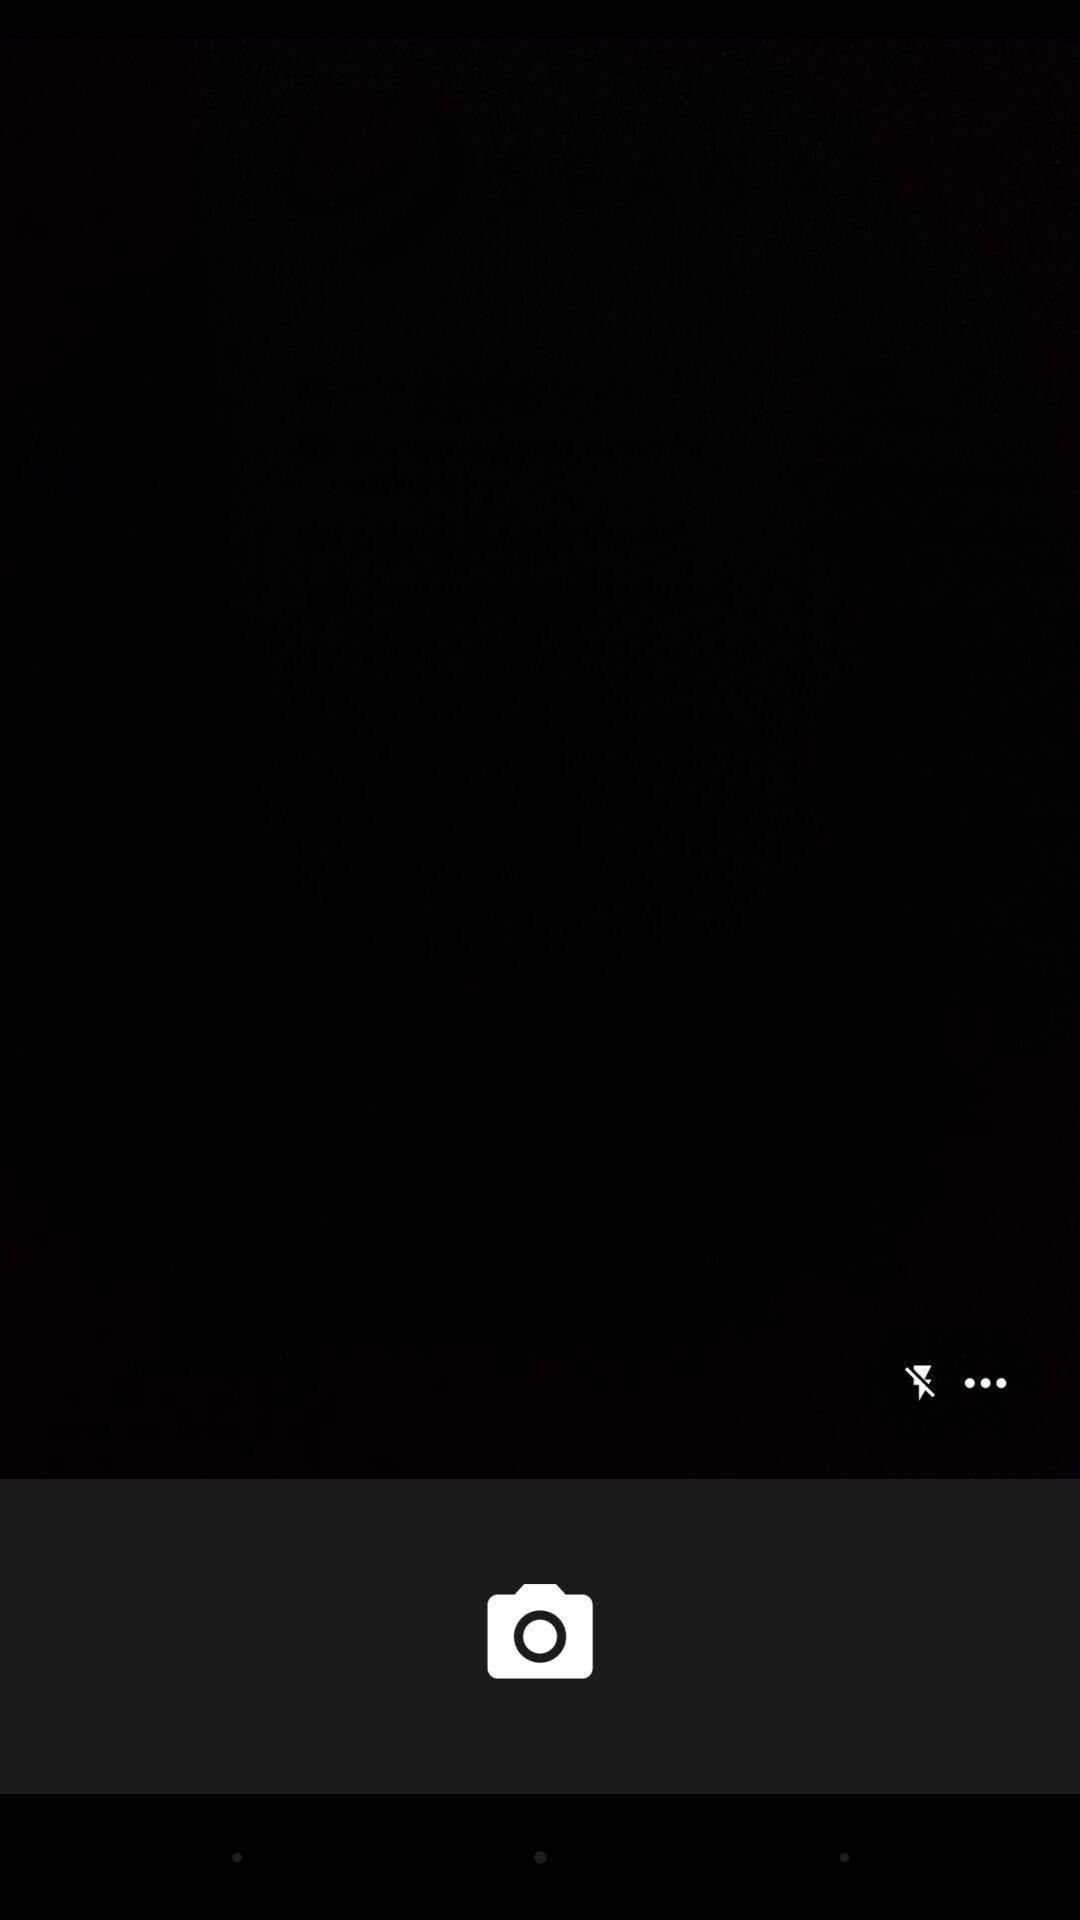Explain the elements present in this screenshot. Screen displaying the camera and flash icon. 